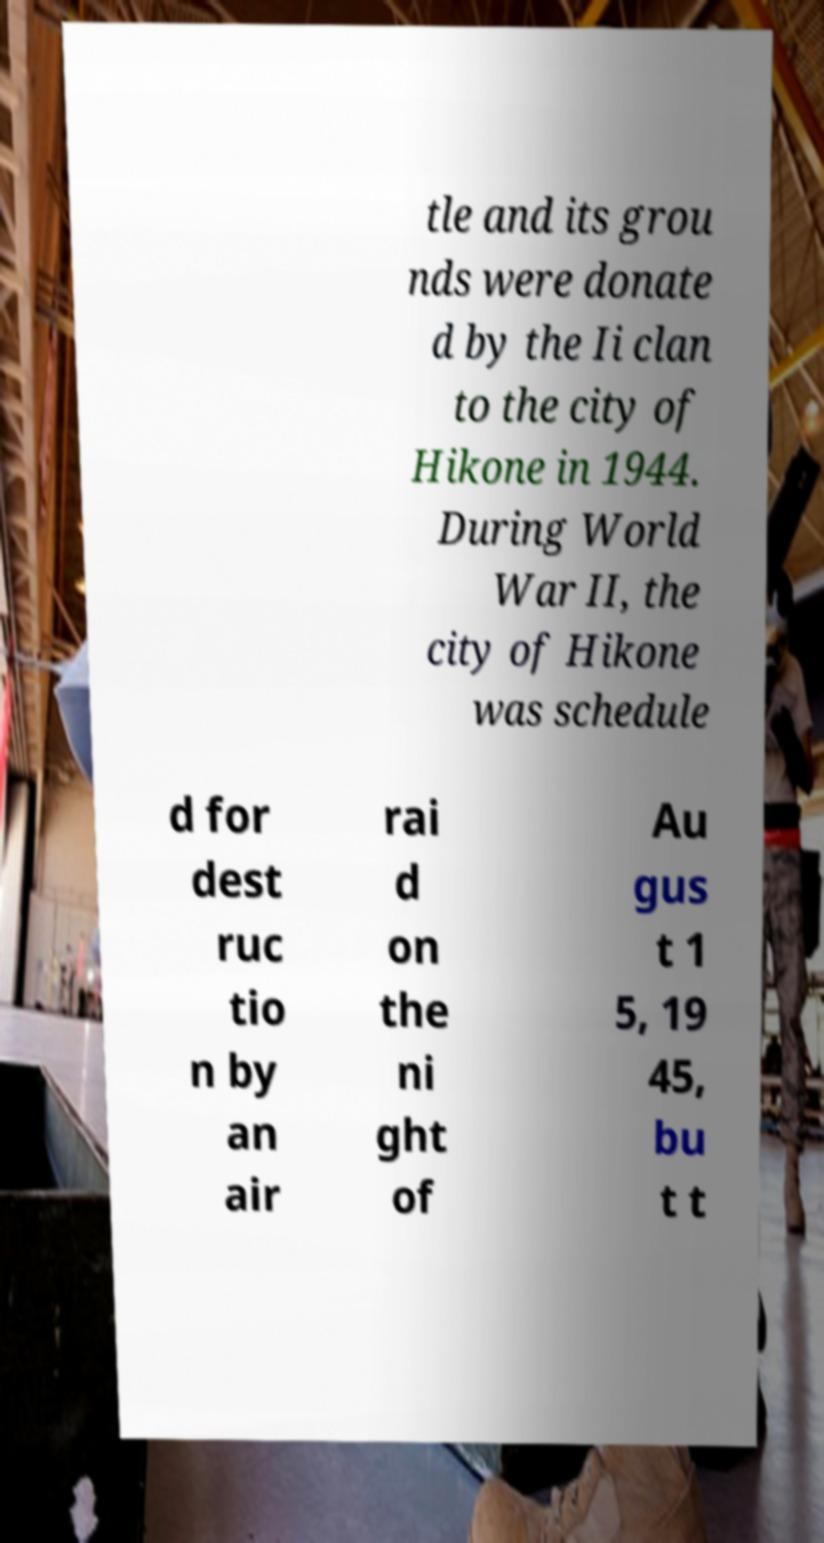What messages or text are displayed in this image? I need them in a readable, typed format. tle and its grou nds were donate d by the Ii clan to the city of Hikone in 1944. During World War II, the city of Hikone was schedule d for dest ruc tio n by an air rai d on the ni ght of Au gus t 1 5, 19 45, bu t t 